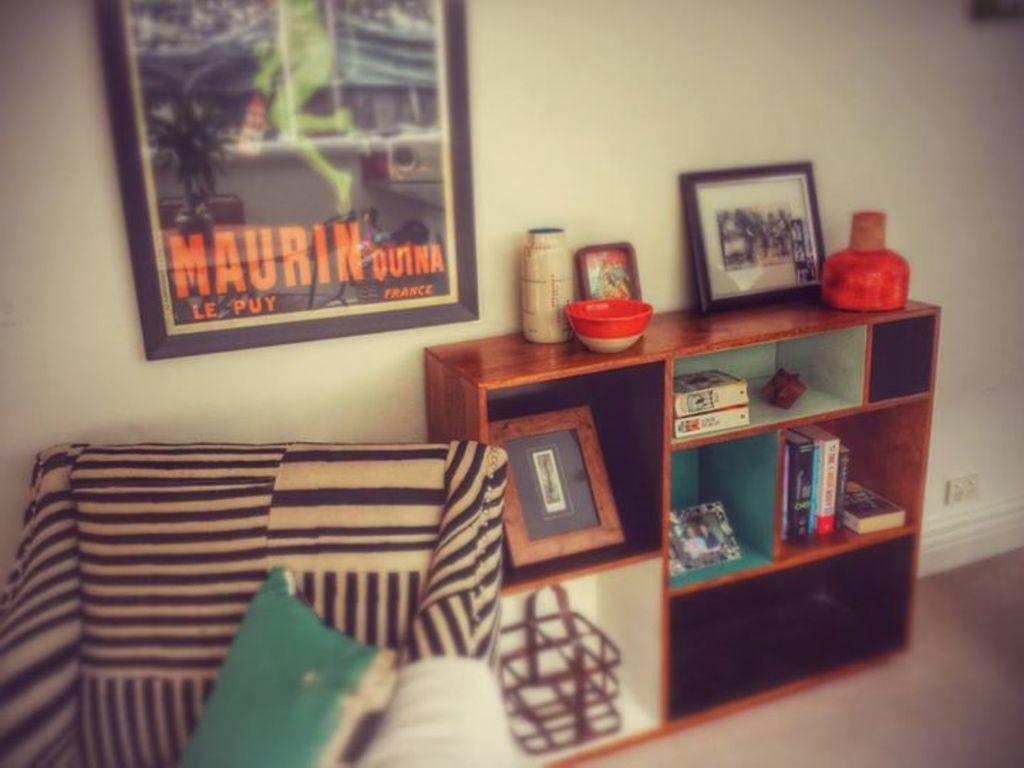<image>
Summarize the visual content of the image. Poster on a wall that says Maurin Quina France. 